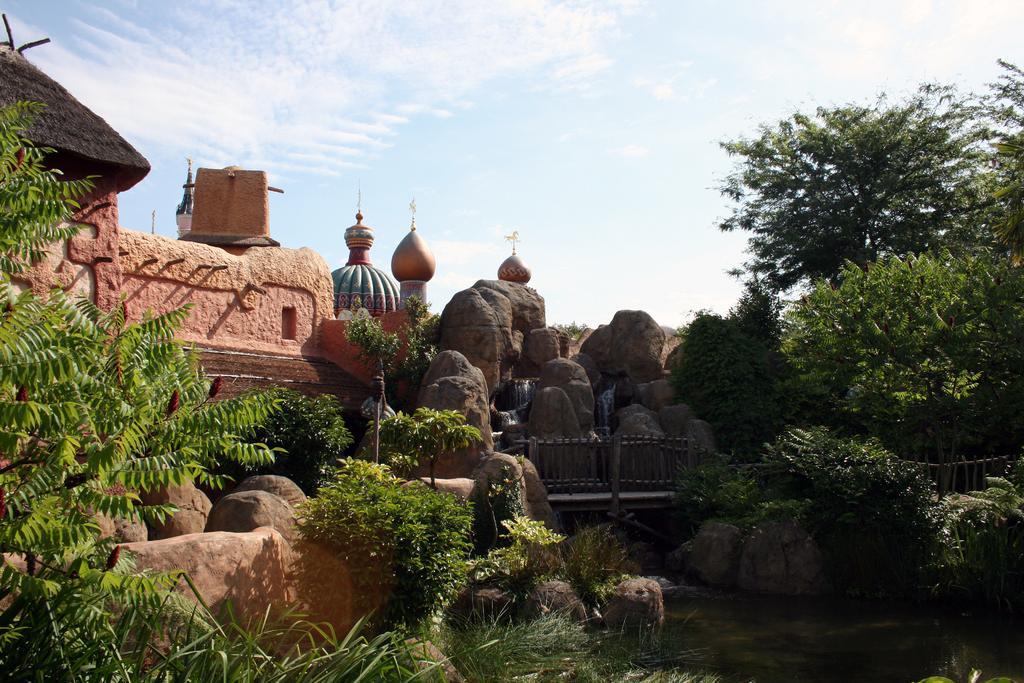Describe this image in one or two sentences. In this image I can see many rocks and trees. To the left I can see the hut. In the background I can see the clouds and the sky. 